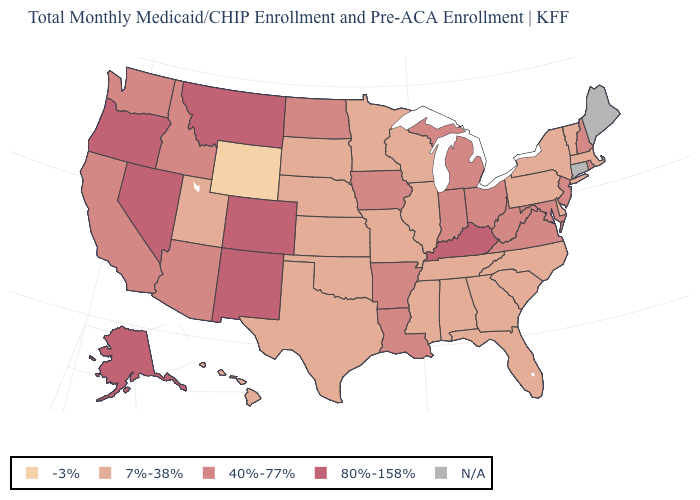Is the legend a continuous bar?
Quick response, please. No. What is the value of Florida?
Quick response, please. 7%-38%. What is the value of Wyoming?
Answer briefly. -3%. Name the states that have a value in the range 80%-158%?
Keep it brief. Alaska, Colorado, Kentucky, Montana, Nevada, New Mexico, Oregon. What is the value of New Mexico?
Short answer required. 80%-158%. Among the states that border New York , which have the lowest value?
Quick response, please. Massachusetts, Pennsylvania, Vermont. What is the lowest value in states that border Maryland?
Quick response, please. 7%-38%. Name the states that have a value in the range 40%-77%?
Concise answer only. Arizona, Arkansas, California, Idaho, Indiana, Iowa, Louisiana, Maryland, Michigan, New Hampshire, New Jersey, North Dakota, Ohio, Rhode Island, Virginia, Washington, West Virginia. What is the value of Wisconsin?
Give a very brief answer. 7%-38%. Name the states that have a value in the range 40%-77%?
Keep it brief. Arizona, Arkansas, California, Idaho, Indiana, Iowa, Louisiana, Maryland, Michigan, New Hampshire, New Jersey, North Dakota, Ohio, Rhode Island, Virginia, Washington, West Virginia. Is the legend a continuous bar?
Write a very short answer. No. What is the value of Alabama?
Short answer required. 7%-38%. 